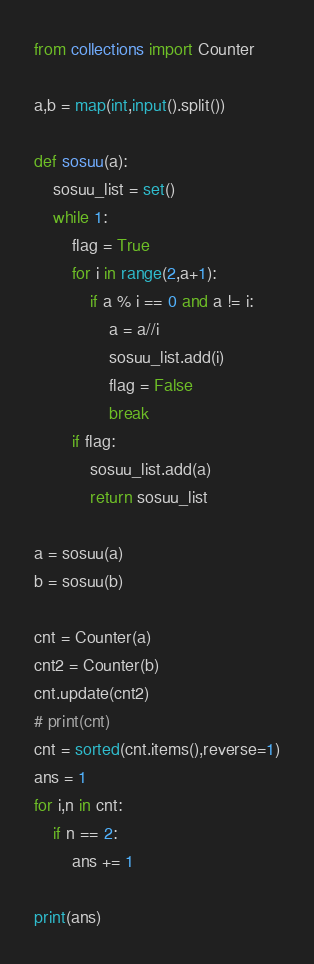<code> <loc_0><loc_0><loc_500><loc_500><_Python_>from collections import Counter

a,b = map(int,input().split())

def sosuu(a):
	sosuu_list = set()
	while 1:
		flag = True
		for i in range(2,a+1):
			if a % i == 0 and a != i:
				a = a//i
				sosuu_list.add(i)
				flag = False
				break
		if flag:
			sosuu_list.add(a)
			return sosuu_list

a = sosuu(a)
b = sosuu(b)

cnt = Counter(a)
cnt2 = Counter(b)
cnt.update(cnt2)
# print(cnt)
cnt = sorted(cnt.items(),reverse=1)
ans = 1
for i,n in cnt:
	if n == 2:
		ans += 1

print(ans)</code> 